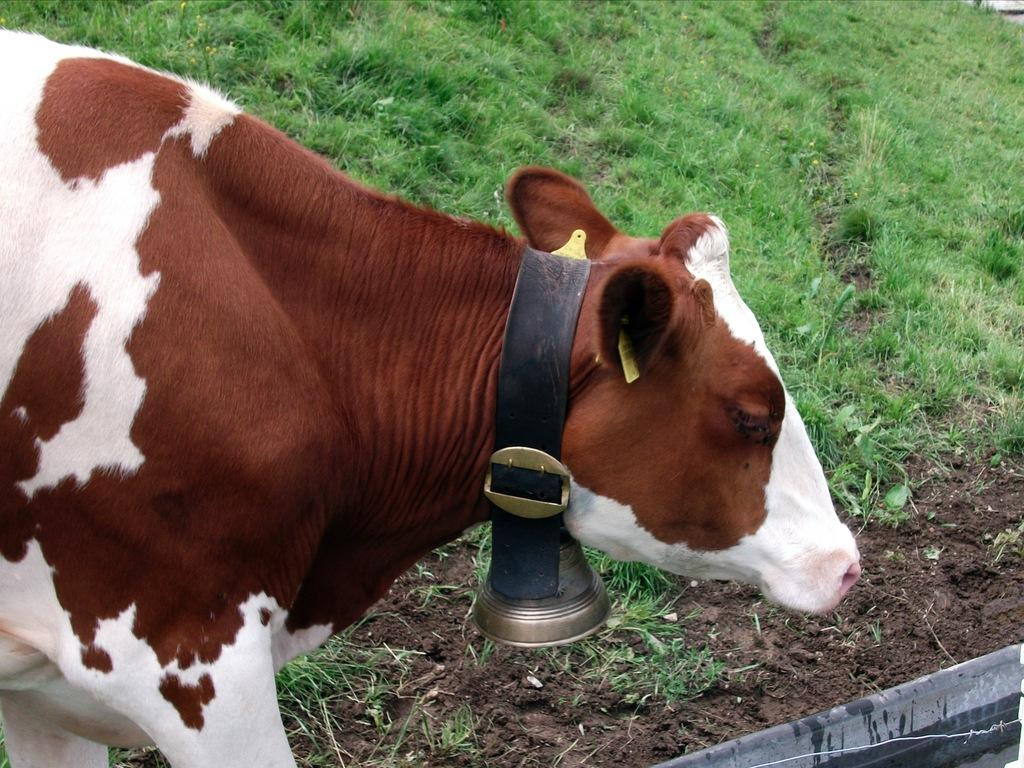What type of animal is in the image? The animal in the image is not specified, but it has a bell attached to its neck. What can be found on the ground in the image? There is grass visible on the ground in the image. What type of pencil is the animal holding in the image? There is no pencil present in the image; the animal has a bell attached to its neck. Is there any evidence of an organization in the image? There is no information about an organization in the image; it only features an animal with a bell and grass on the ground. 